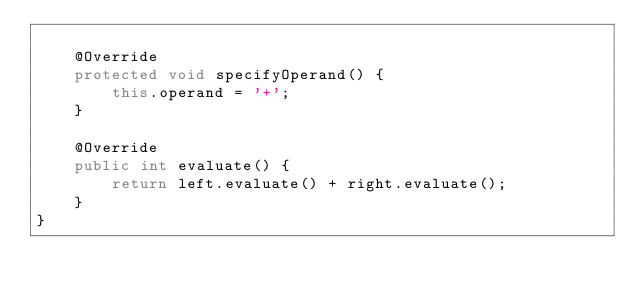<code> <loc_0><loc_0><loc_500><loc_500><_Java_>
    @Override
    protected void specifyOperand() {
        this.operand = '+';
    }

    @Override
    public int evaluate() {
        return left.evaluate() + right.evaluate();
    }
}
</code> 